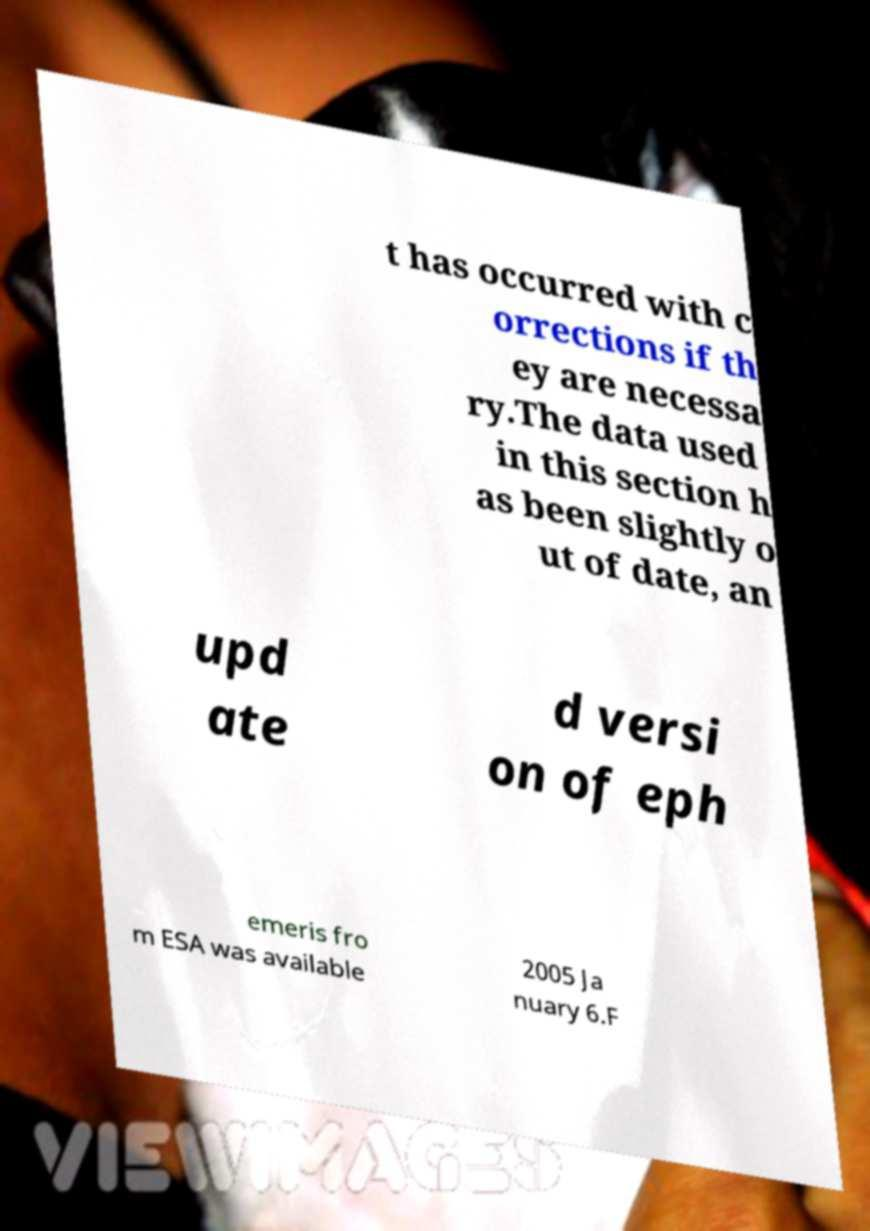What messages or text are displayed in this image? I need them in a readable, typed format. t has occurred with c orrections if th ey are necessa ry.The data used in this section h as been slightly o ut of date, an upd ate d versi on of eph emeris fro m ESA was available 2005 Ja nuary 6.F 